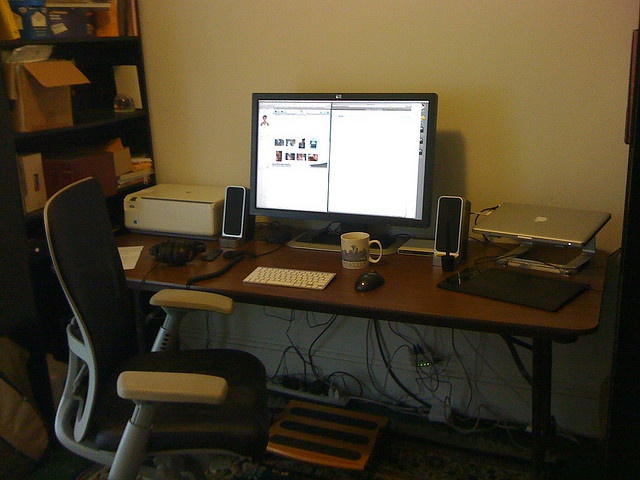Describe the objects in this image and their specific colors. I can see tv in olive, white, black, darkgray, and gray tones, chair in olive, black, and gray tones, laptop in olive, black, and maroon tones, keyboard in olive and tan tones, and cup in olive, black, and maroon tones in this image. 